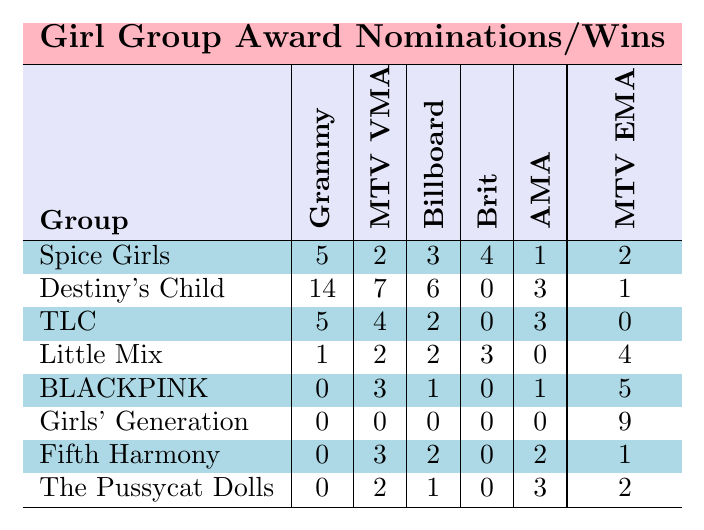What girl group has the highest number of Grammy nominations? Looking at the "Grammy" column, Destiny's Child has the highest number with 14 nominations.
Answer: Destiny's Child How many nominations did BLACKPINK receive at the American Music Awards? In the "AMA" column, BLACKPINK received 1 nomination.
Answer: 1 Which girl group has the most MTV Europe Music Awards wins? In the "MTV EMA" column, Girls' Generation has 9 wins, more than any other group.
Answer: Girls' Generation What is the total number of nominations for TLC across all award shows? Adding TLC's nominations: 5 (Grammy) + 4 (MTV VMA) + 2 (Billboard) + 0 (Brit) + 3 (AMA) + 0 (MTV EMA) = 14 nominations total.
Answer: 14 Do the Spice Girls have more MTV Video Music Awards nominations than Fifth Harmony? The Spice Girls have 2 MTV VMA nominations, while Fifth Harmony has 3, meaning Fifth Harmony has more.
Answer: No How many total wins did BLACKPINK achieve at the MTV Europe Music Awards compared to Girls' Generation? BLACKPINK has 5 wins and Girls' Generation has 9 wins in the MTV EMA column, so Girls' Generation has more.
Answer: Girls' Generation What percentage of Destiny's Child nominations are for the Grammy Awards? Destiny's Child has 14 nominations in total; 14 of those are for the Grammy Awards. Calculating percentage: (14/14) * 100% = 100%.
Answer: 100% Which group has the least number of total nominations across all award shows? Analyzing the total nominations for each group: Spice Girls (17), Destiny's Child (31), TLC (14), Little Mix (8), BLACKPINK (10), Girls' Generation (9), Fifth Harmony (6), The Pussycat Dolls (6). The group with the least is Fifth Harmony and The Pussycat Dolls, both with 6 nominations.
Answer: Fifth Harmony and The Pussycat Dolls What is the average number of nominations for the girl groups in the Brit Awards? Adding the Brit Awards nominations: 4 + 0 + 0 + 3 + 0 + 0 + 0 + 0 = 7. There are 8 groups, so the average is 7/8 = 0.875.
Answer: 0.875 Did any girl group receive more nominations in the Billboard Music Awards than in the Grammy Awards? Checking nominations: Destiny's Child (6 in Billboard, 14 in Grammy), Spice Girls (3 in Billboard, 5 in Grammy), TLC (2 in Billboard, 5 in Grammy), Little Mix (2 in Billboard, 1 in Grammy), BLACKPINK (1 in Billboard, 0 in Grammy), Girls' Generation (0 in Billboard, 0 in Grammy), Fifth Harmony (2 in Billboard, 0 in Grammy), The Pussycat Dolls (1 in Billboard, 0 in Grammy). No group has more nominations in Billboard than Grammy.
Answer: No 